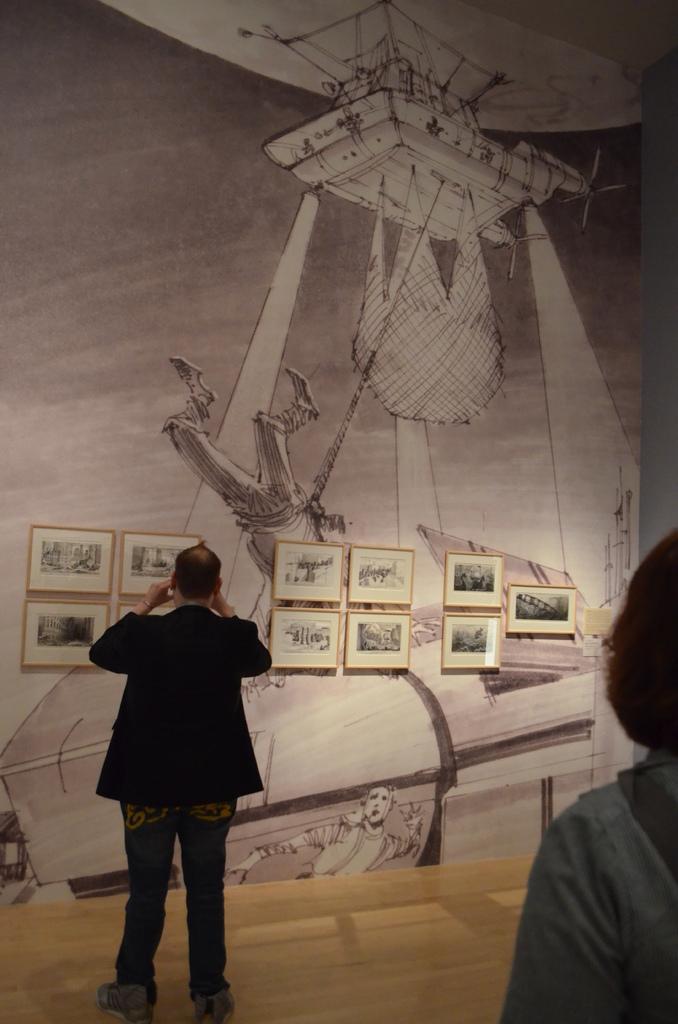Could you give a brief overview of what you see in this image? In this image we can see a person standing on the floor. Behind the person we can see a wall. On the wall we can see the painting and photo frames. In the bottom right we can see another person. 